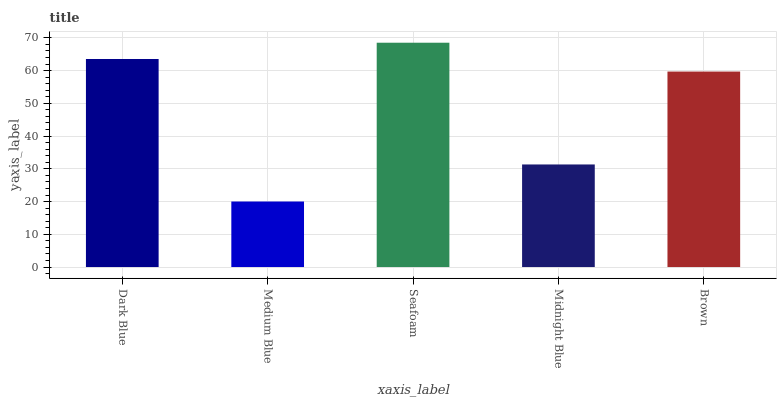Is Medium Blue the minimum?
Answer yes or no. Yes. Is Seafoam the maximum?
Answer yes or no. Yes. Is Seafoam the minimum?
Answer yes or no. No. Is Medium Blue the maximum?
Answer yes or no. No. Is Seafoam greater than Medium Blue?
Answer yes or no. Yes. Is Medium Blue less than Seafoam?
Answer yes or no. Yes. Is Medium Blue greater than Seafoam?
Answer yes or no. No. Is Seafoam less than Medium Blue?
Answer yes or no. No. Is Brown the high median?
Answer yes or no. Yes. Is Brown the low median?
Answer yes or no. Yes. Is Dark Blue the high median?
Answer yes or no. No. Is Dark Blue the low median?
Answer yes or no. No. 